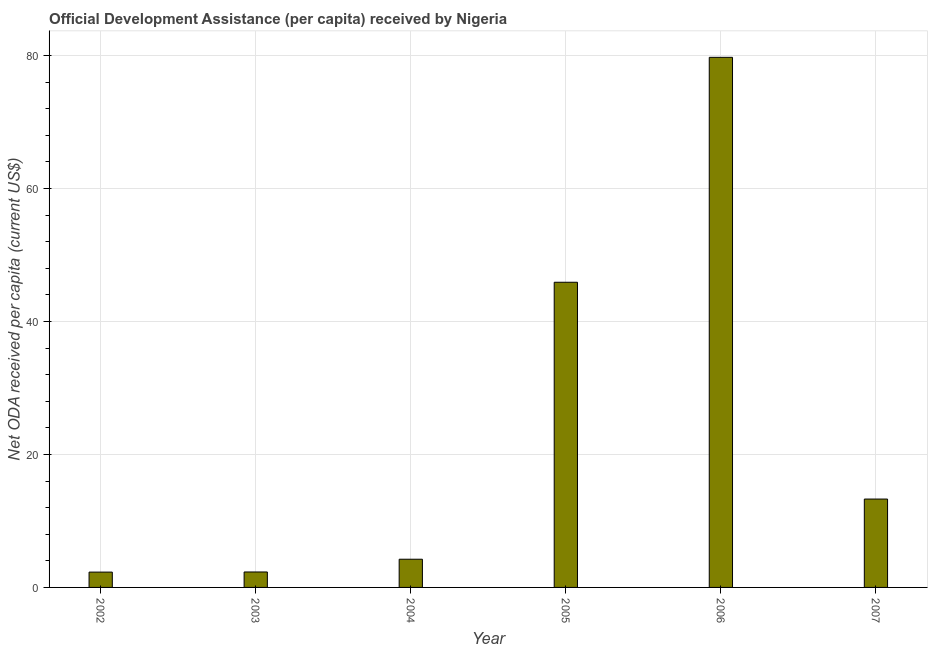Does the graph contain grids?
Give a very brief answer. Yes. What is the title of the graph?
Offer a very short reply. Official Development Assistance (per capita) received by Nigeria. What is the label or title of the Y-axis?
Your answer should be very brief. Net ODA received per capita (current US$). What is the net oda received per capita in 2006?
Make the answer very short. 79.74. Across all years, what is the maximum net oda received per capita?
Keep it short and to the point. 79.74. Across all years, what is the minimum net oda received per capita?
Your answer should be compact. 2.31. What is the sum of the net oda received per capita?
Your answer should be very brief. 147.81. What is the difference between the net oda received per capita in 2004 and 2006?
Provide a succinct answer. -75.5. What is the average net oda received per capita per year?
Your response must be concise. 24.64. What is the median net oda received per capita?
Offer a very short reply. 8.77. In how many years, is the net oda received per capita greater than 56 US$?
Keep it short and to the point. 1. Do a majority of the years between 2003 and 2007 (inclusive) have net oda received per capita greater than 28 US$?
Give a very brief answer. No. What is the ratio of the net oda received per capita in 2003 to that in 2007?
Your answer should be compact. 0.17. Is the net oda received per capita in 2002 less than that in 2007?
Make the answer very short. Yes. What is the difference between the highest and the second highest net oda received per capita?
Make the answer very short. 33.83. Is the sum of the net oda received per capita in 2006 and 2007 greater than the maximum net oda received per capita across all years?
Offer a terse response. Yes. What is the difference between the highest and the lowest net oda received per capita?
Your answer should be compact. 77.43. Are all the bars in the graph horizontal?
Your answer should be very brief. No. How many years are there in the graph?
Your answer should be compact. 6. What is the Net ODA received per capita (current US$) of 2002?
Offer a very short reply. 2.31. What is the Net ODA received per capita (current US$) in 2003?
Offer a terse response. 2.32. What is the Net ODA received per capita (current US$) of 2004?
Offer a very short reply. 4.24. What is the Net ODA received per capita (current US$) in 2005?
Provide a short and direct response. 45.9. What is the Net ODA received per capita (current US$) of 2006?
Offer a terse response. 79.74. What is the Net ODA received per capita (current US$) of 2007?
Offer a terse response. 13.29. What is the difference between the Net ODA received per capita (current US$) in 2002 and 2003?
Your answer should be compact. -0.02. What is the difference between the Net ODA received per capita (current US$) in 2002 and 2004?
Your answer should be very brief. -1.94. What is the difference between the Net ODA received per capita (current US$) in 2002 and 2005?
Provide a succinct answer. -43.6. What is the difference between the Net ODA received per capita (current US$) in 2002 and 2006?
Your answer should be compact. -77.43. What is the difference between the Net ODA received per capita (current US$) in 2002 and 2007?
Your response must be concise. -10.99. What is the difference between the Net ODA received per capita (current US$) in 2003 and 2004?
Offer a very short reply. -1.92. What is the difference between the Net ODA received per capita (current US$) in 2003 and 2005?
Provide a short and direct response. -43.58. What is the difference between the Net ODA received per capita (current US$) in 2003 and 2006?
Keep it short and to the point. -77.41. What is the difference between the Net ODA received per capita (current US$) in 2003 and 2007?
Keep it short and to the point. -10.97. What is the difference between the Net ODA received per capita (current US$) in 2004 and 2005?
Ensure brevity in your answer.  -41.66. What is the difference between the Net ODA received per capita (current US$) in 2004 and 2006?
Provide a short and direct response. -75.5. What is the difference between the Net ODA received per capita (current US$) in 2004 and 2007?
Offer a very short reply. -9.05. What is the difference between the Net ODA received per capita (current US$) in 2005 and 2006?
Ensure brevity in your answer.  -33.83. What is the difference between the Net ODA received per capita (current US$) in 2005 and 2007?
Ensure brevity in your answer.  32.61. What is the difference between the Net ODA received per capita (current US$) in 2006 and 2007?
Offer a very short reply. 66.44. What is the ratio of the Net ODA received per capita (current US$) in 2002 to that in 2004?
Offer a very short reply. 0.54. What is the ratio of the Net ODA received per capita (current US$) in 2002 to that in 2005?
Provide a short and direct response. 0.05. What is the ratio of the Net ODA received per capita (current US$) in 2002 to that in 2006?
Your answer should be very brief. 0.03. What is the ratio of the Net ODA received per capita (current US$) in 2002 to that in 2007?
Offer a very short reply. 0.17. What is the ratio of the Net ODA received per capita (current US$) in 2003 to that in 2004?
Provide a succinct answer. 0.55. What is the ratio of the Net ODA received per capita (current US$) in 2003 to that in 2005?
Offer a terse response. 0.05. What is the ratio of the Net ODA received per capita (current US$) in 2003 to that in 2006?
Make the answer very short. 0.03. What is the ratio of the Net ODA received per capita (current US$) in 2003 to that in 2007?
Offer a terse response. 0.17. What is the ratio of the Net ODA received per capita (current US$) in 2004 to that in 2005?
Your answer should be very brief. 0.09. What is the ratio of the Net ODA received per capita (current US$) in 2004 to that in 2006?
Keep it short and to the point. 0.05. What is the ratio of the Net ODA received per capita (current US$) in 2004 to that in 2007?
Your response must be concise. 0.32. What is the ratio of the Net ODA received per capita (current US$) in 2005 to that in 2006?
Your answer should be compact. 0.58. What is the ratio of the Net ODA received per capita (current US$) in 2005 to that in 2007?
Keep it short and to the point. 3.45. What is the ratio of the Net ODA received per capita (current US$) in 2006 to that in 2007?
Your answer should be very brief. 6. 